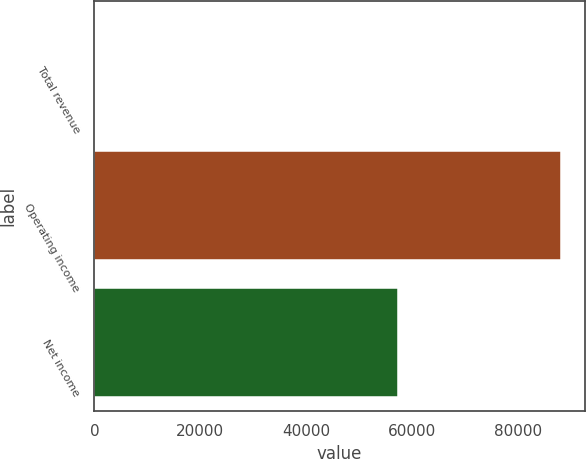Convert chart to OTSL. <chart><loc_0><loc_0><loc_500><loc_500><bar_chart><fcel>Total revenue<fcel>Operating income<fcel>Net income<nl><fcel>103<fcel>88114<fcel>57286<nl></chart> 